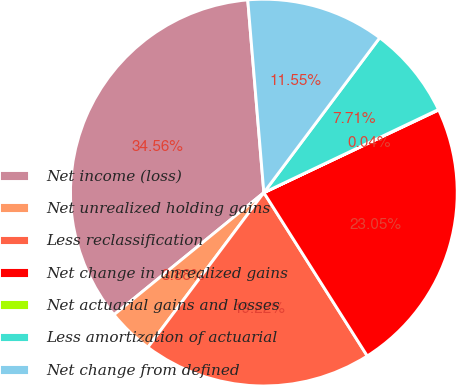<chart> <loc_0><loc_0><loc_500><loc_500><pie_chart><fcel>Net income (loss)<fcel>Net unrealized holding gains<fcel>Less reclassification<fcel>Net change in unrealized gains<fcel>Net actuarial gains and losses<fcel>Less amortization of actuarial<fcel>Net change from defined<nl><fcel>34.56%<fcel>3.88%<fcel>19.22%<fcel>23.05%<fcel>0.04%<fcel>7.71%<fcel>11.55%<nl></chart> 